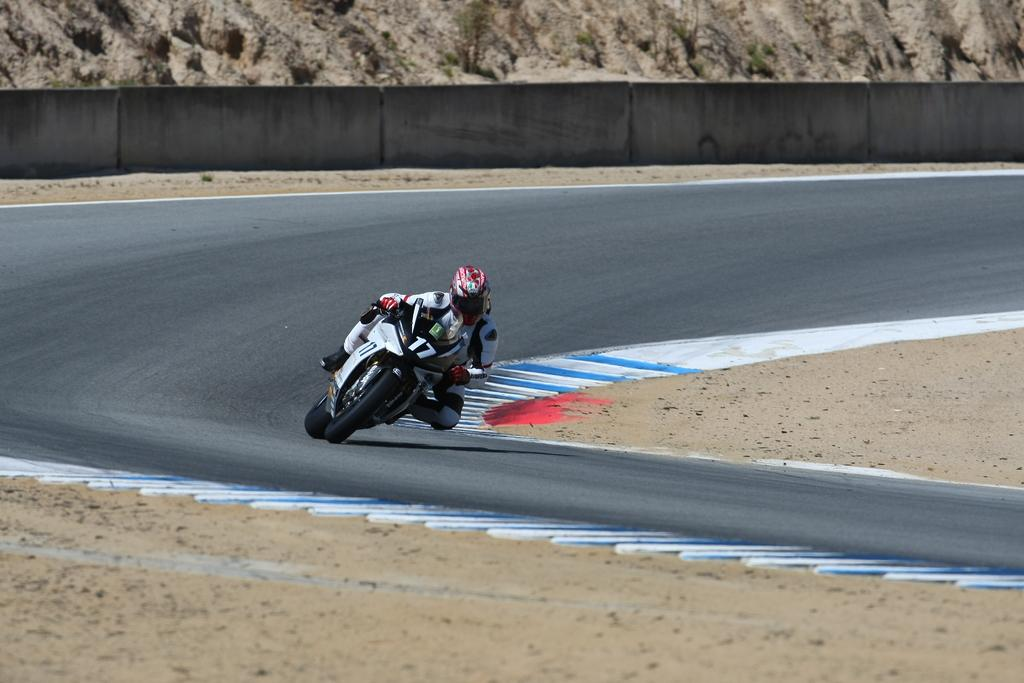What is the main subject of the image? There is a person riding a motorbike in the image. Where is the person riding the motorbike? The person is on the road. What can be seen at the top of the image? There are rocks or sand at the top of the image. What type of bubble is the person riding in the image? There is no bubble present in the image; the person is riding a motorbike on the road. Can you tell me where the market is located in the image? There is no mention of a market in the image; it features a person riding a motorbike on the road with rocks or sand at the top. 